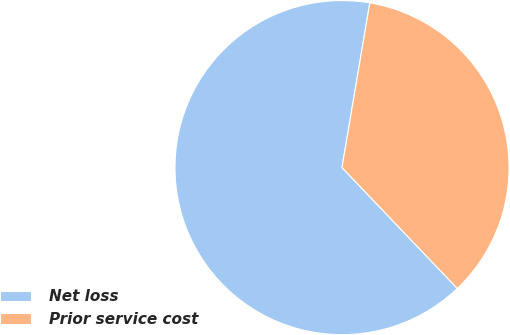<chart> <loc_0><loc_0><loc_500><loc_500><pie_chart><fcel>Net loss<fcel>Prior service cost<nl><fcel>64.79%<fcel>35.21%<nl></chart> 